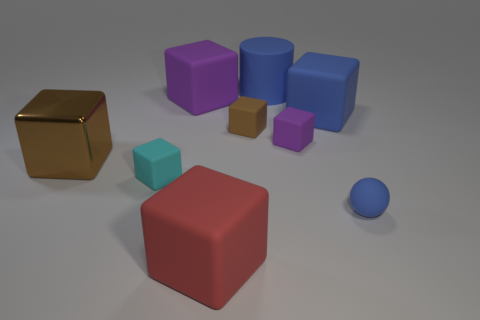Subtract all big metal blocks. How many blocks are left? 6 Add 1 big purple things. How many objects exist? 10 Subtract all brown blocks. How many blocks are left? 5 Subtract all cylinders. How many objects are left? 8 Subtract 1 balls. How many balls are left? 0 Subtract all yellow cylinders. How many cyan blocks are left? 1 Add 5 small blue balls. How many small blue balls are left? 6 Add 1 blue rubber cylinders. How many blue rubber cylinders exist? 2 Subtract 1 blue balls. How many objects are left? 8 Subtract all yellow spheres. Subtract all green cubes. How many spheres are left? 1 